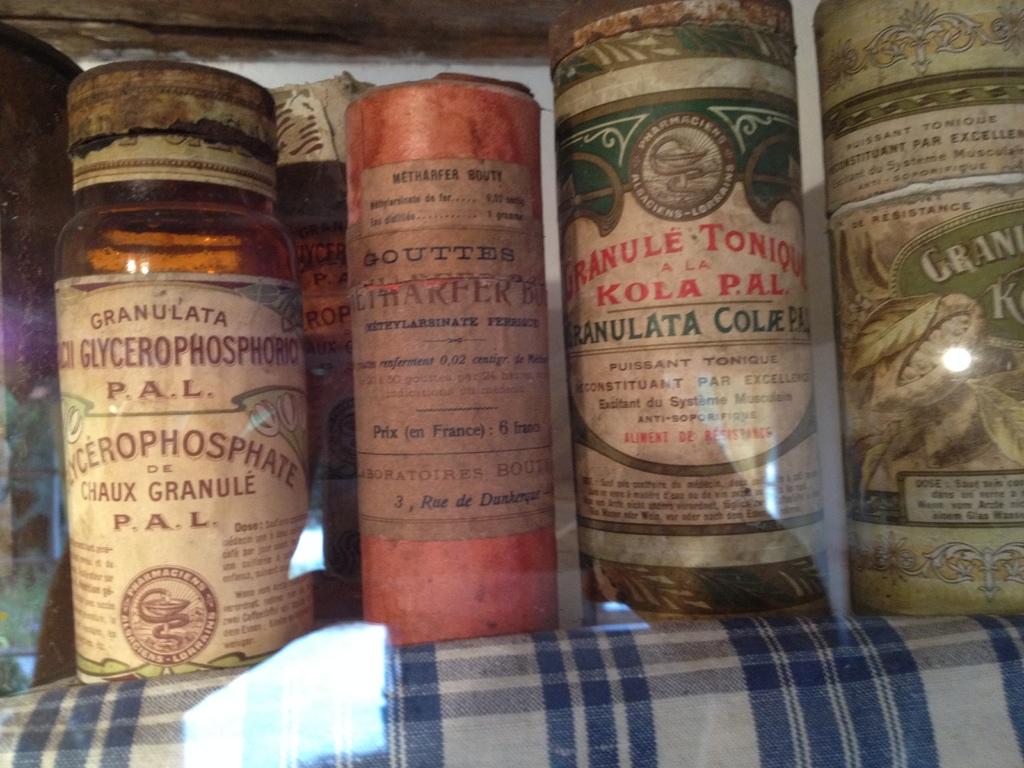How many jars are on the shelf?
Give a very brief answer. Answering does not require reading text in the image. Who makes the jar on the far left?
Your response must be concise. Granulata. 